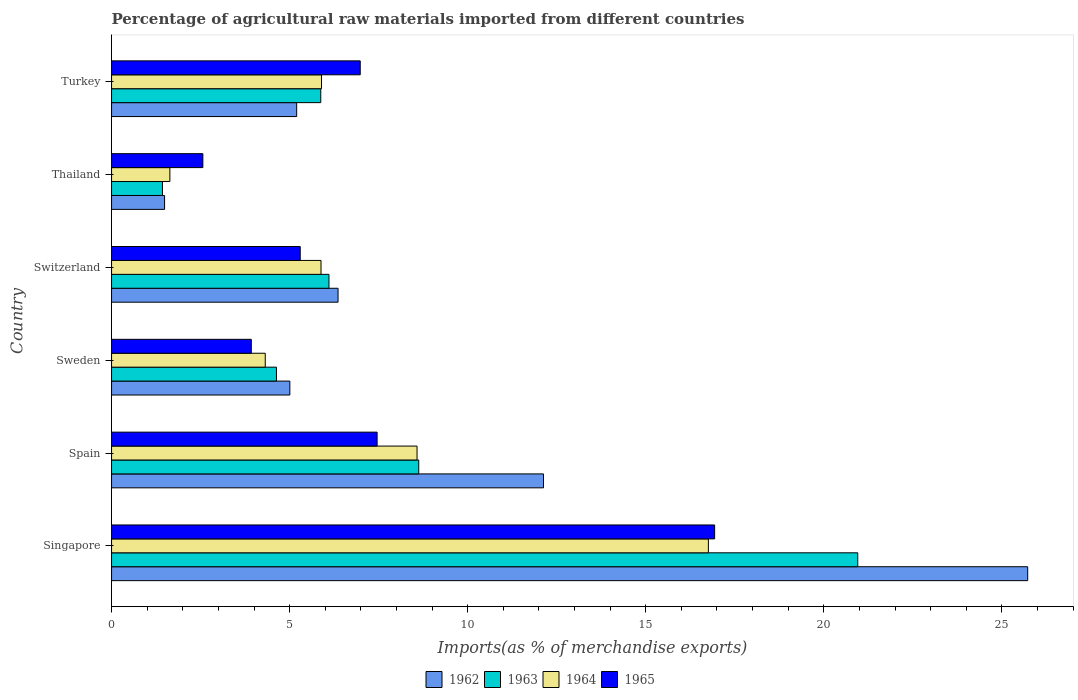Are the number of bars on each tick of the Y-axis equal?
Provide a short and direct response. Yes. How many bars are there on the 5th tick from the bottom?
Offer a very short reply. 4. What is the percentage of imports to different countries in 1964 in Thailand?
Keep it short and to the point. 1.64. Across all countries, what is the maximum percentage of imports to different countries in 1962?
Ensure brevity in your answer.  25.73. Across all countries, what is the minimum percentage of imports to different countries in 1962?
Your answer should be compact. 1.49. In which country was the percentage of imports to different countries in 1965 maximum?
Your answer should be compact. Singapore. In which country was the percentage of imports to different countries in 1964 minimum?
Your response must be concise. Thailand. What is the total percentage of imports to different countries in 1965 in the graph?
Your answer should be compact. 43.16. What is the difference between the percentage of imports to different countries in 1965 in Switzerland and that in Thailand?
Your response must be concise. 2.73. What is the difference between the percentage of imports to different countries in 1962 in Switzerland and the percentage of imports to different countries in 1965 in Spain?
Give a very brief answer. -1.1. What is the average percentage of imports to different countries in 1962 per country?
Your answer should be very brief. 9.32. What is the difference between the percentage of imports to different countries in 1964 and percentage of imports to different countries in 1965 in Switzerland?
Keep it short and to the point. 0.58. In how many countries, is the percentage of imports to different countries in 1962 greater than 18 %?
Keep it short and to the point. 1. What is the ratio of the percentage of imports to different countries in 1962 in Singapore to that in Spain?
Give a very brief answer. 2.12. Is the percentage of imports to different countries in 1962 in Thailand less than that in Turkey?
Ensure brevity in your answer.  Yes. Is the difference between the percentage of imports to different countries in 1964 in Spain and Switzerland greater than the difference between the percentage of imports to different countries in 1965 in Spain and Switzerland?
Your answer should be compact. Yes. What is the difference between the highest and the second highest percentage of imports to different countries in 1965?
Provide a succinct answer. 9.48. What is the difference between the highest and the lowest percentage of imports to different countries in 1962?
Give a very brief answer. 24.24. What does the 3rd bar from the top in Switzerland represents?
Offer a terse response. 1963. What does the 3rd bar from the bottom in Singapore represents?
Ensure brevity in your answer.  1964. Is it the case that in every country, the sum of the percentage of imports to different countries in 1963 and percentage of imports to different countries in 1964 is greater than the percentage of imports to different countries in 1965?
Make the answer very short. Yes. Are all the bars in the graph horizontal?
Give a very brief answer. Yes. What is the difference between two consecutive major ticks on the X-axis?
Offer a terse response. 5. Are the values on the major ticks of X-axis written in scientific E-notation?
Your answer should be compact. No. How many legend labels are there?
Ensure brevity in your answer.  4. How are the legend labels stacked?
Offer a terse response. Horizontal. What is the title of the graph?
Your answer should be very brief. Percentage of agricultural raw materials imported from different countries. What is the label or title of the X-axis?
Your answer should be very brief. Imports(as % of merchandise exports). What is the Imports(as % of merchandise exports) in 1962 in Singapore?
Keep it short and to the point. 25.73. What is the Imports(as % of merchandise exports) of 1963 in Singapore?
Make the answer very short. 20.95. What is the Imports(as % of merchandise exports) of 1964 in Singapore?
Keep it short and to the point. 16.76. What is the Imports(as % of merchandise exports) of 1965 in Singapore?
Your answer should be compact. 16.93. What is the Imports(as % of merchandise exports) of 1962 in Spain?
Your response must be concise. 12.13. What is the Imports(as % of merchandise exports) in 1963 in Spain?
Offer a very short reply. 8.63. What is the Imports(as % of merchandise exports) in 1964 in Spain?
Provide a short and direct response. 8.58. What is the Imports(as % of merchandise exports) in 1965 in Spain?
Offer a terse response. 7.46. What is the Imports(as % of merchandise exports) of 1962 in Sweden?
Offer a very short reply. 5.01. What is the Imports(as % of merchandise exports) in 1963 in Sweden?
Make the answer very short. 4.63. What is the Imports(as % of merchandise exports) of 1964 in Sweden?
Your answer should be very brief. 4.32. What is the Imports(as % of merchandise exports) in 1965 in Sweden?
Provide a succinct answer. 3.92. What is the Imports(as % of merchandise exports) in 1962 in Switzerland?
Provide a short and direct response. 6.36. What is the Imports(as % of merchandise exports) in 1963 in Switzerland?
Provide a succinct answer. 6.1. What is the Imports(as % of merchandise exports) of 1964 in Switzerland?
Provide a short and direct response. 5.88. What is the Imports(as % of merchandise exports) of 1965 in Switzerland?
Offer a terse response. 5.3. What is the Imports(as % of merchandise exports) of 1962 in Thailand?
Ensure brevity in your answer.  1.49. What is the Imports(as % of merchandise exports) of 1963 in Thailand?
Offer a terse response. 1.43. What is the Imports(as % of merchandise exports) in 1964 in Thailand?
Provide a short and direct response. 1.64. What is the Imports(as % of merchandise exports) in 1965 in Thailand?
Provide a short and direct response. 2.56. What is the Imports(as % of merchandise exports) of 1962 in Turkey?
Make the answer very short. 5.2. What is the Imports(as % of merchandise exports) in 1963 in Turkey?
Offer a terse response. 5.87. What is the Imports(as % of merchandise exports) of 1964 in Turkey?
Make the answer very short. 5.9. What is the Imports(as % of merchandise exports) of 1965 in Turkey?
Ensure brevity in your answer.  6.98. Across all countries, what is the maximum Imports(as % of merchandise exports) of 1962?
Provide a succinct answer. 25.73. Across all countries, what is the maximum Imports(as % of merchandise exports) of 1963?
Make the answer very short. 20.95. Across all countries, what is the maximum Imports(as % of merchandise exports) of 1964?
Provide a short and direct response. 16.76. Across all countries, what is the maximum Imports(as % of merchandise exports) in 1965?
Provide a short and direct response. 16.93. Across all countries, what is the minimum Imports(as % of merchandise exports) in 1962?
Your answer should be compact. 1.49. Across all countries, what is the minimum Imports(as % of merchandise exports) of 1963?
Your response must be concise. 1.43. Across all countries, what is the minimum Imports(as % of merchandise exports) of 1964?
Your answer should be compact. 1.64. Across all countries, what is the minimum Imports(as % of merchandise exports) in 1965?
Your answer should be compact. 2.56. What is the total Imports(as % of merchandise exports) of 1962 in the graph?
Give a very brief answer. 55.91. What is the total Imports(as % of merchandise exports) in 1963 in the graph?
Offer a terse response. 47.62. What is the total Imports(as % of merchandise exports) in 1964 in the graph?
Your answer should be very brief. 43.07. What is the total Imports(as % of merchandise exports) of 1965 in the graph?
Keep it short and to the point. 43.16. What is the difference between the Imports(as % of merchandise exports) of 1962 in Singapore and that in Spain?
Your response must be concise. 13.6. What is the difference between the Imports(as % of merchandise exports) in 1963 in Singapore and that in Spain?
Keep it short and to the point. 12.33. What is the difference between the Imports(as % of merchandise exports) in 1964 in Singapore and that in Spain?
Your response must be concise. 8.18. What is the difference between the Imports(as % of merchandise exports) of 1965 in Singapore and that in Spain?
Offer a terse response. 9.48. What is the difference between the Imports(as % of merchandise exports) of 1962 in Singapore and that in Sweden?
Offer a terse response. 20.72. What is the difference between the Imports(as % of merchandise exports) in 1963 in Singapore and that in Sweden?
Ensure brevity in your answer.  16.32. What is the difference between the Imports(as % of merchandise exports) in 1964 in Singapore and that in Sweden?
Give a very brief answer. 12.44. What is the difference between the Imports(as % of merchandise exports) of 1965 in Singapore and that in Sweden?
Make the answer very short. 13.01. What is the difference between the Imports(as % of merchandise exports) in 1962 in Singapore and that in Switzerland?
Make the answer very short. 19.37. What is the difference between the Imports(as % of merchandise exports) in 1963 in Singapore and that in Switzerland?
Ensure brevity in your answer.  14.85. What is the difference between the Imports(as % of merchandise exports) of 1964 in Singapore and that in Switzerland?
Ensure brevity in your answer.  10.88. What is the difference between the Imports(as % of merchandise exports) in 1965 in Singapore and that in Switzerland?
Your answer should be very brief. 11.64. What is the difference between the Imports(as % of merchandise exports) of 1962 in Singapore and that in Thailand?
Ensure brevity in your answer.  24.24. What is the difference between the Imports(as % of merchandise exports) in 1963 in Singapore and that in Thailand?
Offer a terse response. 19.52. What is the difference between the Imports(as % of merchandise exports) of 1964 in Singapore and that in Thailand?
Ensure brevity in your answer.  15.12. What is the difference between the Imports(as % of merchandise exports) of 1965 in Singapore and that in Thailand?
Provide a succinct answer. 14.37. What is the difference between the Imports(as % of merchandise exports) of 1962 in Singapore and that in Turkey?
Provide a succinct answer. 20.53. What is the difference between the Imports(as % of merchandise exports) in 1963 in Singapore and that in Turkey?
Your response must be concise. 15.08. What is the difference between the Imports(as % of merchandise exports) of 1964 in Singapore and that in Turkey?
Provide a short and direct response. 10.86. What is the difference between the Imports(as % of merchandise exports) of 1965 in Singapore and that in Turkey?
Give a very brief answer. 9.95. What is the difference between the Imports(as % of merchandise exports) of 1962 in Spain and that in Sweden?
Provide a succinct answer. 7.12. What is the difference between the Imports(as % of merchandise exports) in 1963 in Spain and that in Sweden?
Provide a succinct answer. 4. What is the difference between the Imports(as % of merchandise exports) in 1964 in Spain and that in Sweden?
Give a very brief answer. 4.26. What is the difference between the Imports(as % of merchandise exports) of 1965 in Spain and that in Sweden?
Your answer should be very brief. 3.53. What is the difference between the Imports(as % of merchandise exports) of 1962 in Spain and that in Switzerland?
Offer a terse response. 5.77. What is the difference between the Imports(as % of merchandise exports) of 1963 in Spain and that in Switzerland?
Your answer should be compact. 2.52. What is the difference between the Imports(as % of merchandise exports) of 1964 in Spain and that in Switzerland?
Give a very brief answer. 2.7. What is the difference between the Imports(as % of merchandise exports) of 1965 in Spain and that in Switzerland?
Your answer should be compact. 2.16. What is the difference between the Imports(as % of merchandise exports) of 1962 in Spain and that in Thailand?
Make the answer very short. 10.64. What is the difference between the Imports(as % of merchandise exports) of 1963 in Spain and that in Thailand?
Offer a terse response. 7.2. What is the difference between the Imports(as % of merchandise exports) of 1964 in Spain and that in Thailand?
Offer a very short reply. 6.94. What is the difference between the Imports(as % of merchandise exports) in 1965 in Spain and that in Thailand?
Your answer should be compact. 4.89. What is the difference between the Imports(as % of merchandise exports) in 1962 in Spain and that in Turkey?
Your answer should be very brief. 6.93. What is the difference between the Imports(as % of merchandise exports) of 1963 in Spain and that in Turkey?
Provide a short and direct response. 2.75. What is the difference between the Imports(as % of merchandise exports) in 1964 in Spain and that in Turkey?
Offer a terse response. 2.68. What is the difference between the Imports(as % of merchandise exports) in 1965 in Spain and that in Turkey?
Provide a short and direct response. 0.47. What is the difference between the Imports(as % of merchandise exports) in 1962 in Sweden and that in Switzerland?
Offer a very short reply. -1.35. What is the difference between the Imports(as % of merchandise exports) in 1963 in Sweden and that in Switzerland?
Make the answer very short. -1.47. What is the difference between the Imports(as % of merchandise exports) in 1964 in Sweden and that in Switzerland?
Your answer should be very brief. -1.57. What is the difference between the Imports(as % of merchandise exports) of 1965 in Sweden and that in Switzerland?
Make the answer very short. -1.37. What is the difference between the Imports(as % of merchandise exports) in 1962 in Sweden and that in Thailand?
Offer a terse response. 3.52. What is the difference between the Imports(as % of merchandise exports) in 1963 in Sweden and that in Thailand?
Keep it short and to the point. 3.2. What is the difference between the Imports(as % of merchandise exports) in 1964 in Sweden and that in Thailand?
Your answer should be very brief. 2.68. What is the difference between the Imports(as % of merchandise exports) of 1965 in Sweden and that in Thailand?
Ensure brevity in your answer.  1.36. What is the difference between the Imports(as % of merchandise exports) in 1962 in Sweden and that in Turkey?
Make the answer very short. -0.19. What is the difference between the Imports(as % of merchandise exports) in 1963 in Sweden and that in Turkey?
Provide a short and direct response. -1.24. What is the difference between the Imports(as % of merchandise exports) of 1964 in Sweden and that in Turkey?
Provide a short and direct response. -1.58. What is the difference between the Imports(as % of merchandise exports) of 1965 in Sweden and that in Turkey?
Provide a short and direct response. -3.06. What is the difference between the Imports(as % of merchandise exports) in 1962 in Switzerland and that in Thailand?
Keep it short and to the point. 4.87. What is the difference between the Imports(as % of merchandise exports) of 1963 in Switzerland and that in Thailand?
Keep it short and to the point. 4.68. What is the difference between the Imports(as % of merchandise exports) of 1964 in Switzerland and that in Thailand?
Make the answer very short. 4.24. What is the difference between the Imports(as % of merchandise exports) in 1965 in Switzerland and that in Thailand?
Provide a succinct answer. 2.73. What is the difference between the Imports(as % of merchandise exports) of 1962 in Switzerland and that in Turkey?
Provide a succinct answer. 1.16. What is the difference between the Imports(as % of merchandise exports) of 1963 in Switzerland and that in Turkey?
Keep it short and to the point. 0.23. What is the difference between the Imports(as % of merchandise exports) in 1964 in Switzerland and that in Turkey?
Your response must be concise. -0.01. What is the difference between the Imports(as % of merchandise exports) in 1965 in Switzerland and that in Turkey?
Your response must be concise. -1.69. What is the difference between the Imports(as % of merchandise exports) in 1962 in Thailand and that in Turkey?
Your response must be concise. -3.71. What is the difference between the Imports(as % of merchandise exports) in 1963 in Thailand and that in Turkey?
Your response must be concise. -4.45. What is the difference between the Imports(as % of merchandise exports) of 1964 in Thailand and that in Turkey?
Provide a short and direct response. -4.26. What is the difference between the Imports(as % of merchandise exports) in 1965 in Thailand and that in Turkey?
Offer a very short reply. -4.42. What is the difference between the Imports(as % of merchandise exports) in 1962 in Singapore and the Imports(as % of merchandise exports) in 1963 in Spain?
Provide a short and direct response. 17.1. What is the difference between the Imports(as % of merchandise exports) in 1962 in Singapore and the Imports(as % of merchandise exports) in 1964 in Spain?
Your answer should be very brief. 17.15. What is the difference between the Imports(as % of merchandise exports) in 1962 in Singapore and the Imports(as % of merchandise exports) in 1965 in Spain?
Offer a very short reply. 18.27. What is the difference between the Imports(as % of merchandise exports) of 1963 in Singapore and the Imports(as % of merchandise exports) of 1964 in Spain?
Your answer should be compact. 12.38. What is the difference between the Imports(as % of merchandise exports) of 1963 in Singapore and the Imports(as % of merchandise exports) of 1965 in Spain?
Your answer should be very brief. 13.5. What is the difference between the Imports(as % of merchandise exports) of 1964 in Singapore and the Imports(as % of merchandise exports) of 1965 in Spain?
Provide a short and direct response. 9.3. What is the difference between the Imports(as % of merchandise exports) of 1962 in Singapore and the Imports(as % of merchandise exports) of 1963 in Sweden?
Provide a succinct answer. 21.09. What is the difference between the Imports(as % of merchandise exports) of 1962 in Singapore and the Imports(as % of merchandise exports) of 1964 in Sweden?
Provide a short and direct response. 21.41. What is the difference between the Imports(as % of merchandise exports) in 1962 in Singapore and the Imports(as % of merchandise exports) in 1965 in Sweden?
Give a very brief answer. 21.8. What is the difference between the Imports(as % of merchandise exports) of 1963 in Singapore and the Imports(as % of merchandise exports) of 1964 in Sweden?
Make the answer very short. 16.64. What is the difference between the Imports(as % of merchandise exports) in 1963 in Singapore and the Imports(as % of merchandise exports) in 1965 in Sweden?
Ensure brevity in your answer.  17.03. What is the difference between the Imports(as % of merchandise exports) in 1964 in Singapore and the Imports(as % of merchandise exports) in 1965 in Sweden?
Provide a short and direct response. 12.83. What is the difference between the Imports(as % of merchandise exports) in 1962 in Singapore and the Imports(as % of merchandise exports) in 1963 in Switzerland?
Ensure brevity in your answer.  19.62. What is the difference between the Imports(as % of merchandise exports) of 1962 in Singapore and the Imports(as % of merchandise exports) of 1964 in Switzerland?
Your answer should be very brief. 19.84. What is the difference between the Imports(as % of merchandise exports) of 1962 in Singapore and the Imports(as % of merchandise exports) of 1965 in Switzerland?
Your answer should be compact. 20.43. What is the difference between the Imports(as % of merchandise exports) in 1963 in Singapore and the Imports(as % of merchandise exports) in 1964 in Switzerland?
Give a very brief answer. 15.07. What is the difference between the Imports(as % of merchandise exports) of 1963 in Singapore and the Imports(as % of merchandise exports) of 1965 in Switzerland?
Provide a succinct answer. 15.66. What is the difference between the Imports(as % of merchandise exports) in 1964 in Singapore and the Imports(as % of merchandise exports) in 1965 in Switzerland?
Give a very brief answer. 11.46. What is the difference between the Imports(as % of merchandise exports) of 1962 in Singapore and the Imports(as % of merchandise exports) of 1963 in Thailand?
Keep it short and to the point. 24.3. What is the difference between the Imports(as % of merchandise exports) of 1962 in Singapore and the Imports(as % of merchandise exports) of 1964 in Thailand?
Your response must be concise. 24.09. What is the difference between the Imports(as % of merchandise exports) in 1962 in Singapore and the Imports(as % of merchandise exports) in 1965 in Thailand?
Your answer should be compact. 23.16. What is the difference between the Imports(as % of merchandise exports) of 1963 in Singapore and the Imports(as % of merchandise exports) of 1964 in Thailand?
Provide a short and direct response. 19.32. What is the difference between the Imports(as % of merchandise exports) in 1963 in Singapore and the Imports(as % of merchandise exports) in 1965 in Thailand?
Give a very brief answer. 18.39. What is the difference between the Imports(as % of merchandise exports) in 1964 in Singapore and the Imports(as % of merchandise exports) in 1965 in Thailand?
Your answer should be very brief. 14.2. What is the difference between the Imports(as % of merchandise exports) in 1962 in Singapore and the Imports(as % of merchandise exports) in 1963 in Turkey?
Offer a very short reply. 19.85. What is the difference between the Imports(as % of merchandise exports) of 1962 in Singapore and the Imports(as % of merchandise exports) of 1964 in Turkey?
Your response must be concise. 19.83. What is the difference between the Imports(as % of merchandise exports) of 1962 in Singapore and the Imports(as % of merchandise exports) of 1965 in Turkey?
Your answer should be compact. 18.74. What is the difference between the Imports(as % of merchandise exports) of 1963 in Singapore and the Imports(as % of merchandise exports) of 1964 in Turkey?
Your answer should be compact. 15.06. What is the difference between the Imports(as % of merchandise exports) in 1963 in Singapore and the Imports(as % of merchandise exports) in 1965 in Turkey?
Give a very brief answer. 13.97. What is the difference between the Imports(as % of merchandise exports) of 1964 in Singapore and the Imports(as % of merchandise exports) of 1965 in Turkey?
Your answer should be compact. 9.78. What is the difference between the Imports(as % of merchandise exports) of 1962 in Spain and the Imports(as % of merchandise exports) of 1963 in Sweden?
Your answer should be compact. 7.5. What is the difference between the Imports(as % of merchandise exports) in 1962 in Spain and the Imports(as % of merchandise exports) in 1964 in Sweden?
Provide a short and direct response. 7.81. What is the difference between the Imports(as % of merchandise exports) of 1962 in Spain and the Imports(as % of merchandise exports) of 1965 in Sweden?
Make the answer very short. 8.21. What is the difference between the Imports(as % of merchandise exports) in 1963 in Spain and the Imports(as % of merchandise exports) in 1964 in Sweden?
Ensure brevity in your answer.  4.31. What is the difference between the Imports(as % of merchandise exports) of 1963 in Spain and the Imports(as % of merchandise exports) of 1965 in Sweden?
Offer a very short reply. 4.7. What is the difference between the Imports(as % of merchandise exports) of 1964 in Spain and the Imports(as % of merchandise exports) of 1965 in Sweden?
Keep it short and to the point. 4.65. What is the difference between the Imports(as % of merchandise exports) of 1962 in Spain and the Imports(as % of merchandise exports) of 1963 in Switzerland?
Your answer should be very brief. 6.02. What is the difference between the Imports(as % of merchandise exports) in 1962 in Spain and the Imports(as % of merchandise exports) in 1964 in Switzerland?
Your answer should be compact. 6.25. What is the difference between the Imports(as % of merchandise exports) in 1962 in Spain and the Imports(as % of merchandise exports) in 1965 in Switzerland?
Keep it short and to the point. 6.83. What is the difference between the Imports(as % of merchandise exports) of 1963 in Spain and the Imports(as % of merchandise exports) of 1964 in Switzerland?
Your answer should be very brief. 2.74. What is the difference between the Imports(as % of merchandise exports) of 1963 in Spain and the Imports(as % of merchandise exports) of 1965 in Switzerland?
Your answer should be very brief. 3.33. What is the difference between the Imports(as % of merchandise exports) in 1964 in Spain and the Imports(as % of merchandise exports) in 1965 in Switzerland?
Your answer should be compact. 3.28. What is the difference between the Imports(as % of merchandise exports) of 1962 in Spain and the Imports(as % of merchandise exports) of 1963 in Thailand?
Ensure brevity in your answer.  10.7. What is the difference between the Imports(as % of merchandise exports) in 1962 in Spain and the Imports(as % of merchandise exports) in 1964 in Thailand?
Provide a short and direct response. 10.49. What is the difference between the Imports(as % of merchandise exports) of 1962 in Spain and the Imports(as % of merchandise exports) of 1965 in Thailand?
Provide a succinct answer. 9.57. What is the difference between the Imports(as % of merchandise exports) of 1963 in Spain and the Imports(as % of merchandise exports) of 1964 in Thailand?
Give a very brief answer. 6.99. What is the difference between the Imports(as % of merchandise exports) of 1963 in Spain and the Imports(as % of merchandise exports) of 1965 in Thailand?
Keep it short and to the point. 6.06. What is the difference between the Imports(as % of merchandise exports) in 1964 in Spain and the Imports(as % of merchandise exports) in 1965 in Thailand?
Your answer should be very brief. 6.01. What is the difference between the Imports(as % of merchandise exports) in 1962 in Spain and the Imports(as % of merchandise exports) in 1963 in Turkey?
Provide a succinct answer. 6.25. What is the difference between the Imports(as % of merchandise exports) of 1962 in Spain and the Imports(as % of merchandise exports) of 1964 in Turkey?
Ensure brevity in your answer.  6.23. What is the difference between the Imports(as % of merchandise exports) in 1962 in Spain and the Imports(as % of merchandise exports) in 1965 in Turkey?
Keep it short and to the point. 5.15. What is the difference between the Imports(as % of merchandise exports) in 1963 in Spain and the Imports(as % of merchandise exports) in 1964 in Turkey?
Keep it short and to the point. 2.73. What is the difference between the Imports(as % of merchandise exports) in 1963 in Spain and the Imports(as % of merchandise exports) in 1965 in Turkey?
Your response must be concise. 1.64. What is the difference between the Imports(as % of merchandise exports) of 1964 in Spain and the Imports(as % of merchandise exports) of 1965 in Turkey?
Offer a very short reply. 1.6. What is the difference between the Imports(as % of merchandise exports) in 1962 in Sweden and the Imports(as % of merchandise exports) in 1963 in Switzerland?
Provide a succinct answer. -1.1. What is the difference between the Imports(as % of merchandise exports) of 1962 in Sweden and the Imports(as % of merchandise exports) of 1964 in Switzerland?
Make the answer very short. -0.88. What is the difference between the Imports(as % of merchandise exports) in 1962 in Sweden and the Imports(as % of merchandise exports) in 1965 in Switzerland?
Your response must be concise. -0.29. What is the difference between the Imports(as % of merchandise exports) in 1963 in Sweden and the Imports(as % of merchandise exports) in 1964 in Switzerland?
Give a very brief answer. -1.25. What is the difference between the Imports(as % of merchandise exports) of 1963 in Sweden and the Imports(as % of merchandise exports) of 1965 in Switzerland?
Make the answer very short. -0.67. What is the difference between the Imports(as % of merchandise exports) of 1964 in Sweden and the Imports(as % of merchandise exports) of 1965 in Switzerland?
Keep it short and to the point. -0.98. What is the difference between the Imports(as % of merchandise exports) in 1962 in Sweden and the Imports(as % of merchandise exports) in 1963 in Thailand?
Offer a very short reply. 3.58. What is the difference between the Imports(as % of merchandise exports) in 1962 in Sweden and the Imports(as % of merchandise exports) in 1964 in Thailand?
Make the answer very short. 3.37. What is the difference between the Imports(as % of merchandise exports) of 1962 in Sweden and the Imports(as % of merchandise exports) of 1965 in Thailand?
Your answer should be compact. 2.44. What is the difference between the Imports(as % of merchandise exports) in 1963 in Sweden and the Imports(as % of merchandise exports) in 1964 in Thailand?
Make the answer very short. 2.99. What is the difference between the Imports(as % of merchandise exports) of 1963 in Sweden and the Imports(as % of merchandise exports) of 1965 in Thailand?
Provide a succinct answer. 2.07. What is the difference between the Imports(as % of merchandise exports) of 1964 in Sweden and the Imports(as % of merchandise exports) of 1965 in Thailand?
Offer a terse response. 1.75. What is the difference between the Imports(as % of merchandise exports) of 1962 in Sweden and the Imports(as % of merchandise exports) of 1963 in Turkey?
Provide a succinct answer. -0.87. What is the difference between the Imports(as % of merchandise exports) of 1962 in Sweden and the Imports(as % of merchandise exports) of 1964 in Turkey?
Your answer should be very brief. -0.89. What is the difference between the Imports(as % of merchandise exports) of 1962 in Sweden and the Imports(as % of merchandise exports) of 1965 in Turkey?
Give a very brief answer. -1.98. What is the difference between the Imports(as % of merchandise exports) of 1963 in Sweden and the Imports(as % of merchandise exports) of 1964 in Turkey?
Your answer should be compact. -1.27. What is the difference between the Imports(as % of merchandise exports) in 1963 in Sweden and the Imports(as % of merchandise exports) in 1965 in Turkey?
Make the answer very short. -2.35. What is the difference between the Imports(as % of merchandise exports) of 1964 in Sweden and the Imports(as % of merchandise exports) of 1965 in Turkey?
Your answer should be compact. -2.67. What is the difference between the Imports(as % of merchandise exports) in 1962 in Switzerland and the Imports(as % of merchandise exports) in 1963 in Thailand?
Ensure brevity in your answer.  4.93. What is the difference between the Imports(as % of merchandise exports) of 1962 in Switzerland and the Imports(as % of merchandise exports) of 1964 in Thailand?
Give a very brief answer. 4.72. What is the difference between the Imports(as % of merchandise exports) of 1962 in Switzerland and the Imports(as % of merchandise exports) of 1965 in Thailand?
Your answer should be compact. 3.8. What is the difference between the Imports(as % of merchandise exports) of 1963 in Switzerland and the Imports(as % of merchandise exports) of 1964 in Thailand?
Your response must be concise. 4.47. What is the difference between the Imports(as % of merchandise exports) in 1963 in Switzerland and the Imports(as % of merchandise exports) in 1965 in Thailand?
Make the answer very short. 3.54. What is the difference between the Imports(as % of merchandise exports) of 1964 in Switzerland and the Imports(as % of merchandise exports) of 1965 in Thailand?
Provide a short and direct response. 3.32. What is the difference between the Imports(as % of merchandise exports) of 1962 in Switzerland and the Imports(as % of merchandise exports) of 1963 in Turkey?
Offer a very short reply. 0.49. What is the difference between the Imports(as % of merchandise exports) of 1962 in Switzerland and the Imports(as % of merchandise exports) of 1964 in Turkey?
Offer a very short reply. 0.46. What is the difference between the Imports(as % of merchandise exports) in 1962 in Switzerland and the Imports(as % of merchandise exports) in 1965 in Turkey?
Your response must be concise. -0.62. What is the difference between the Imports(as % of merchandise exports) of 1963 in Switzerland and the Imports(as % of merchandise exports) of 1964 in Turkey?
Offer a very short reply. 0.21. What is the difference between the Imports(as % of merchandise exports) in 1963 in Switzerland and the Imports(as % of merchandise exports) in 1965 in Turkey?
Give a very brief answer. -0.88. What is the difference between the Imports(as % of merchandise exports) of 1964 in Switzerland and the Imports(as % of merchandise exports) of 1965 in Turkey?
Your answer should be compact. -1.1. What is the difference between the Imports(as % of merchandise exports) of 1962 in Thailand and the Imports(as % of merchandise exports) of 1963 in Turkey?
Offer a very short reply. -4.39. What is the difference between the Imports(as % of merchandise exports) in 1962 in Thailand and the Imports(as % of merchandise exports) in 1964 in Turkey?
Keep it short and to the point. -4.41. What is the difference between the Imports(as % of merchandise exports) of 1962 in Thailand and the Imports(as % of merchandise exports) of 1965 in Turkey?
Offer a terse response. -5.49. What is the difference between the Imports(as % of merchandise exports) of 1963 in Thailand and the Imports(as % of merchandise exports) of 1964 in Turkey?
Provide a short and direct response. -4.47. What is the difference between the Imports(as % of merchandise exports) of 1963 in Thailand and the Imports(as % of merchandise exports) of 1965 in Turkey?
Offer a terse response. -5.55. What is the difference between the Imports(as % of merchandise exports) of 1964 in Thailand and the Imports(as % of merchandise exports) of 1965 in Turkey?
Offer a very short reply. -5.35. What is the average Imports(as % of merchandise exports) of 1962 per country?
Make the answer very short. 9.32. What is the average Imports(as % of merchandise exports) of 1963 per country?
Offer a very short reply. 7.94. What is the average Imports(as % of merchandise exports) of 1964 per country?
Offer a very short reply. 7.18. What is the average Imports(as % of merchandise exports) of 1965 per country?
Provide a succinct answer. 7.19. What is the difference between the Imports(as % of merchandise exports) of 1962 and Imports(as % of merchandise exports) of 1963 in Singapore?
Offer a terse response. 4.77. What is the difference between the Imports(as % of merchandise exports) in 1962 and Imports(as % of merchandise exports) in 1964 in Singapore?
Make the answer very short. 8.97. What is the difference between the Imports(as % of merchandise exports) of 1962 and Imports(as % of merchandise exports) of 1965 in Singapore?
Your answer should be very brief. 8.79. What is the difference between the Imports(as % of merchandise exports) of 1963 and Imports(as % of merchandise exports) of 1964 in Singapore?
Provide a succinct answer. 4.19. What is the difference between the Imports(as % of merchandise exports) of 1963 and Imports(as % of merchandise exports) of 1965 in Singapore?
Make the answer very short. 4.02. What is the difference between the Imports(as % of merchandise exports) of 1964 and Imports(as % of merchandise exports) of 1965 in Singapore?
Your answer should be compact. -0.18. What is the difference between the Imports(as % of merchandise exports) in 1962 and Imports(as % of merchandise exports) in 1963 in Spain?
Your answer should be compact. 3.5. What is the difference between the Imports(as % of merchandise exports) of 1962 and Imports(as % of merchandise exports) of 1964 in Spain?
Give a very brief answer. 3.55. What is the difference between the Imports(as % of merchandise exports) in 1962 and Imports(as % of merchandise exports) in 1965 in Spain?
Your answer should be compact. 4.67. What is the difference between the Imports(as % of merchandise exports) in 1963 and Imports(as % of merchandise exports) in 1964 in Spain?
Make the answer very short. 0.05. What is the difference between the Imports(as % of merchandise exports) in 1963 and Imports(as % of merchandise exports) in 1965 in Spain?
Your answer should be compact. 1.17. What is the difference between the Imports(as % of merchandise exports) of 1964 and Imports(as % of merchandise exports) of 1965 in Spain?
Make the answer very short. 1.12. What is the difference between the Imports(as % of merchandise exports) of 1962 and Imports(as % of merchandise exports) of 1963 in Sweden?
Offer a terse response. 0.38. What is the difference between the Imports(as % of merchandise exports) in 1962 and Imports(as % of merchandise exports) in 1964 in Sweden?
Keep it short and to the point. 0.69. What is the difference between the Imports(as % of merchandise exports) of 1962 and Imports(as % of merchandise exports) of 1965 in Sweden?
Ensure brevity in your answer.  1.08. What is the difference between the Imports(as % of merchandise exports) in 1963 and Imports(as % of merchandise exports) in 1964 in Sweden?
Your answer should be compact. 0.31. What is the difference between the Imports(as % of merchandise exports) in 1963 and Imports(as % of merchandise exports) in 1965 in Sweden?
Your response must be concise. 0.71. What is the difference between the Imports(as % of merchandise exports) of 1964 and Imports(as % of merchandise exports) of 1965 in Sweden?
Provide a short and direct response. 0.39. What is the difference between the Imports(as % of merchandise exports) of 1962 and Imports(as % of merchandise exports) of 1963 in Switzerland?
Make the answer very short. 0.26. What is the difference between the Imports(as % of merchandise exports) in 1962 and Imports(as % of merchandise exports) in 1964 in Switzerland?
Your answer should be compact. 0.48. What is the difference between the Imports(as % of merchandise exports) of 1962 and Imports(as % of merchandise exports) of 1965 in Switzerland?
Your answer should be very brief. 1.06. What is the difference between the Imports(as % of merchandise exports) of 1963 and Imports(as % of merchandise exports) of 1964 in Switzerland?
Your answer should be very brief. 0.22. What is the difference between the Imports(as % of merchandise exports) of 1963 and Imports(as % of merchandise exports) of 1965 in Switzerland?
Make the answer very short. 0.81. What is the difference between the Imports(as % of merchandise exports) in 1964 and Imports(as % of merchandise exports) in 1965 in Switzerland?
Keep it short and to the point. 0.58. What is the difference between the Imports(as % of merchandise exports) in 1962 and Imports(as % of merchandise exports) in 1963 in Thailand?
Give a very brief answer. 0.06. What is the difference between the Imports(as % of merchandise exports) of 1962 and Imports(as % of merchandise exports) of 1964 in Thailand?
Provide a succinct answer. -0.15. What is the difference between the Imports(as % of merchandise exports) in 1962 and Imports(as % of merchandise exports) in 1965 in Thailand?
Ensure brevity in your answer.  -1.08. What is the difference between the Imports(as % of merchandise exports) in 1963 and Imports(as % of merchandise exports) in 1964 in Thailand?
Offer a very short reply. -0.21. What is the difference between the Imports(as % of merchandise exports) in 1963 and Imports(as % of merchandise exports) in 1965 in Thailand?
Your response must be concise. -1.13. What is the difference between the Imports(as % of merchandise exports) of 1964 and Imports(as % of merchandise exports) of 1965 in Thailand?
Give a very brief answer. -0.93. What is the difference between the Imports(as % of merchandise exports) in 1962 and Imports(as % of merchandise exports) in 1963 in Turkey?
Offer a very short reply. -0.68. What is the difference between the Imports(as % of merchandise exports) in 1962 and Imports(as % of merchandise exports) in 1964 in Turkey?
Provide a short and direct response. -0.7. What is the difference between the Imports(as % of merchandise exports) in 1962 and Imports(as % of merchandise exports) in 1965 in Turkey?
Offer a very short reply. -1.78. What is the difference between the Imports(as % of merchandise exports) in 1963 and Imports(as % of merchandise exports) in 1964 in Turkey?
Your answer should be very brief. -0.02. What is the difference between the Imports(as % of merchandise exports) in 1963 and Imports(as % of merchandise exports) in 1965 in Turkey?
Your answer should be compact. -1.11. What is the difference between the Imports(as % of merchandise exports) of 1964 and Imports(as % of merchandise exports) of 1965 in Turkey?
Offer a terse response. -1.09. What is the ratio of the Imports(as % of merchandise exports) of 1962 in Singapore to that in Spain?
Your answer should be compact. 2.12. What is the ratio of the Imports(as % of merchandise exports) of 1963 in Singapore to that in Spain?
Your response must be concise. 2.43. What is the ratio of the Imports(as % of merchandise exports) in 1964 in Singapore to that in Spain?
Make the answer very short. 1.95. What is the ratio of the Imports(as % of merchandise exports) in 1965 in Singapore to that in Spain?
Give a very brief answer. 2.27. What is the ratio of the Imports(as % of merchandise exports) in 1962 in Singapore to that in Sweden?
Offer a terse response. 5.14. What is the ratio of the Imports(as % of merchandise exports) in 1963 in Singapore to that in Sweden?
Give a very brief answer. 4.53. What is the ratio of the Imports(as % of merchandise exports) in 1964 in Singapore to that in Sweden?
Ensure brevity in your answer.  3.88. What is the ratio of the Imports(as % of merchandise exports) of 1965 in Singapore to that in Sweden?
Offer a terse response. 4.32. What is the ratio of the Imports(as % of merchandise exports) of 1962 in Singapore to that in Switzerland?
Provide a succinct answer. 4.04. What is the ratio of the Imports(as % of merchandise exports) of 1963 in Singapore to that in Switzerland?
Your answer should be very brief. 3.43. What is the ratio of the Imports(as % of merchandise exports) of 1964 in Singapore to that in Switzerland?
Your answer should be compact. 2.85. What is the ratio of the Imports(as % of merchandise exports) in 1965 in Singapore to that in Switzerland?
Make the answer very short. 3.2. What is the ratio of the Imports(as % of merchandise exports) of 1962 in Singapore to that in Thailand?
Ensure brevity in your answer.  17.28. What is the ratio of the Imports(as % of merchandise exports) in 1963 in Singapore to that in Thailand?
Make the answer very short. 14.66. What is the ratio of the Imports(as % of merchandise exports) in 1964 in Singapore to that in Thailand?
Your response must be concise. 10.23. What is the ratio of the Imports(as % of merchandise exports) of 1965 in Singapore to that in Thailand?
Provide a short and direct response. 6.6. What is the ratio of the Imports(as % of merchandise exports) in 1962 in Singapore to that in Turkey?
Offer a terse response. 4.95. What is the ratio of the Imports(as % of merchandise exports) of 1963 in Singapore to that in Turkey?
Keep it short and to the point. 3.57. What is the ratio of the Imports(as % of merchandise exports) in 1964 in Singapore to that in Turkey?
Provide a succinct answer. 2.84. What is the ratio of the Imports(as % of merchandise exports) in 1965 in Singapore to that in Turkey?
Ensure brevity in your answer.  2.43. What is the ratio of the Imports(as % of merchandise exports) in 1962 in Spain to that in Sweden?
Offer a very short reply. 2.42. What is the ratio of the Imports(as % of merchandise exports) of 1963 in Spain to that in Sweden?
Keep it short and to the point. 1.86. What is the ratio of the Imports(as % of merchandise exports) of 1964 in Spain to that in Sweden?
Provide a succinct answer. 1.99. What is the ratio of the Imports(as % of merchandise exports) in 1965 in Spain to that in Sweden?
Your response must be concise. 1.9. What is the ratio of the Imports(as % of merchandise exports) of 1962 in Spain to that in Switzerland?
Give a very brief answer. 1.91. What is the ratio of the Imports(as % of merchandise exports) of 1963 in Spain to that in Switzerland?
Ensure brevity in your answer.  1.41. What is the ratio of the Imports(as % of merchandise exports) of 1964 in Spain to that in Switzerland?
Provide a short and direct response. 1.46. What is the ratio of the Imports(as % of merchandise exports) of 1965 in Spain to that in Switzerland?
Keep it short and to the point. 1.41. What is the ratio of the Imports(as % of merchandise exports) in 1962 in Spain to that in Thailand?
Keep it short and to the point. 8.15. What is the ratio of the Imports(as % of merchandise exports) of 1963 in Spain to that in Thailand?
Offer a very short reply. 6.03. What is the ratio of the Imports(as % of merchandise exports) of 1964 in Spain to that in Thailand?
Offer a terse response. 5.24. What is the ratio of the Imports(as % of merchandise exports) of 1965 in Spain to that in Thailand?
Ensure brevity in your answer.  2.91. What is the ratio of the Imports(as % of merchandise exports) of 1962 in Spain to that in Turkey?
Give a very brief answer. 2.33. What is the ratio of the Imports(as % of merchandise exports) in 1963 in Spain to that in Turkey?
Provide a short and direct response. 1.47. What is the ratio of the Imports(as % of merchandise exports) in 1964 in Spain to that in Turkey?
Offer a terse response. 1.46. What is the ratio of the Imports(as % of merchandise exports) in 1965 in Spain to that in Turkey?
Provide a succinct answer. 1.07. What is the ratio of the Imports(as % of merchandise exports) in 1962 in Sweden to that in Switzerland?
Offer a very short reply. 0.79. What is the ratio of the Imports(as % of merchandise exports) in 1963 in Sweden to that in Switzerland?
Give a very brief answer. 0.76. What is the ratio of the Imports(as % of merchandise exports) in 1964 in Sweden to that in Switzerland?
Your answer should be very brief. 0.73. What is the ratio of the Imports(as % of merchandise exports) of 1965 in Sweden to that in Switzerland?
Keep it short and to the point. 0.74. What is the ratio of the Imports(as % of merchandise exports) in 1962 in Sweden to that in Thailand?
Keep it short and to the point. 3.36. What is the ratio of the Imports(as % of merchandise exports) of 1963 in Sweden to that in Thailand?
Offer a terse response. 3.24. What is the ratio of the Imports(as % of merchandise exports) in 1964 in Sweden to that in Thailand?
Offer a terse response. 2.64. What is the ratio of the Imports(as % of merchandise exports) of 1965 in Sweden to that in Thailand?
Give a very brief answer. 1.53. What is the ratio of the Imports(as % of merchandise exports) in 1963 in Sweden to that in Turkey?
Provide a succinct answer. 0.79. What is the ratio of the Imports(as % of merchandise exports) of 1964 in Sweden to that in Turkey?
Keep it short and to the point. 0.73. What is the ratio of the Imports(as % of merchandise exports) of 1965 in Sweden to that in Turkey?
Offer a terse response. 0.56. What is the ratio of the Imports(as % of merchandise exports) of 1962 in Switzerland to that in Thailand?
Your answer should be very brief. 4.27. What is the ratio of the Imports(as % of merchandise exports) of 1963 in Switzerland to that in Thailand?
Provide a short and direct response. 4.27. What is the ratio of the Imports(as % of merchandise exports) in 1964 in Switzerland to that in Thailand?
Your response must be concise. 3.59. What is the ratio of the Imports(as % of merchandise exports) of 1965 in Switzerland to that in Thailand?
Provide a short and direct response. 2.07. What is the ratio of the Imports(as % of merchandise exports) in 1962 in Switzerland to that in Turkey?
Offer a very short reply. 1.22. What is the ratio of the Imports(as % of merchandise exports) of 1963 in Switzerland to that in Turkey?
Keep it short and to the point. 1.04. What is the ratio of the Imports(as % of merchandise exports) in 1964 in Switzerland to that in Turkey?
Offer a terse response. 1. What is the ratio of the Imports(as % of merchandise exports) in 1965 in Switzerland to that in Turkey?
Ensure brevity in your answer.  0.76. What is the ratio of the Imports(as % of merchandise exports) of 1962 in Thailand to that in Turkey?
Your response must be concise. 0.29. What is the ratio of the Imports(as % of merchandise exports) in 1963 in Thailand to that in Turkey?
Your answer should be compact. 0.24. What is the ratio of the Imports(as % of merchandise exports) in 1964 in Thailand to that in Turkey?
Offer a terse response. 0.28. What is the ratio of the Imports(as % of merchandise exports) in 1965 in Thailand to that in Turkey?
Offer a terse response. 0.37. What is the difference between the highest and the second highest Imports(as % of merchandise exports) of 1962?
Make the answer very short. 13.6. What is the difference between the highest and the second highest Imports(as % of merchandise exports) of 1963?
Give a very brief answer. 12.33. What is the difference between the highest and the second highest Imports(as % of merchandise exports) in 1964?
Give a very brief answer. 8.18. What is the difference between the highest and the second highest Imports(as % of merchandise exports) of 1965?
Your answer should be very brief. 9.48. What is the difference between the highest and the lowest Imports(as % of merchandise exports) in 1962?
Provide a short and direct response. 24.24. What is the difference between the highest and the lowest Imports(as % of merchandise exports) of 1963?
Your response must be concise. 19.52. What is the difference between the highest and the lowest Imports(as % of merchandise exports) in 1964?
Your response must be concise. 15.12. What is the difference between the highest and the lowest Imports(as % of merchandise exports) of 1965?
Keep it short and to the point. 14.37. 